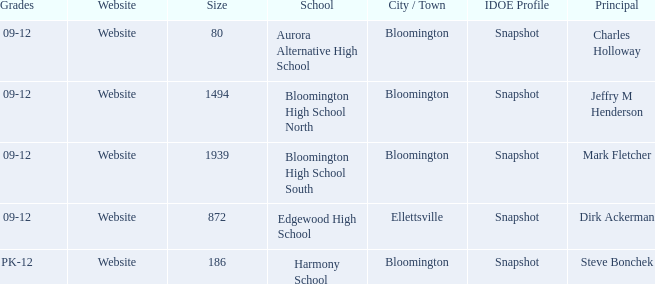Where is Bloomington High School North? Bloomington. 